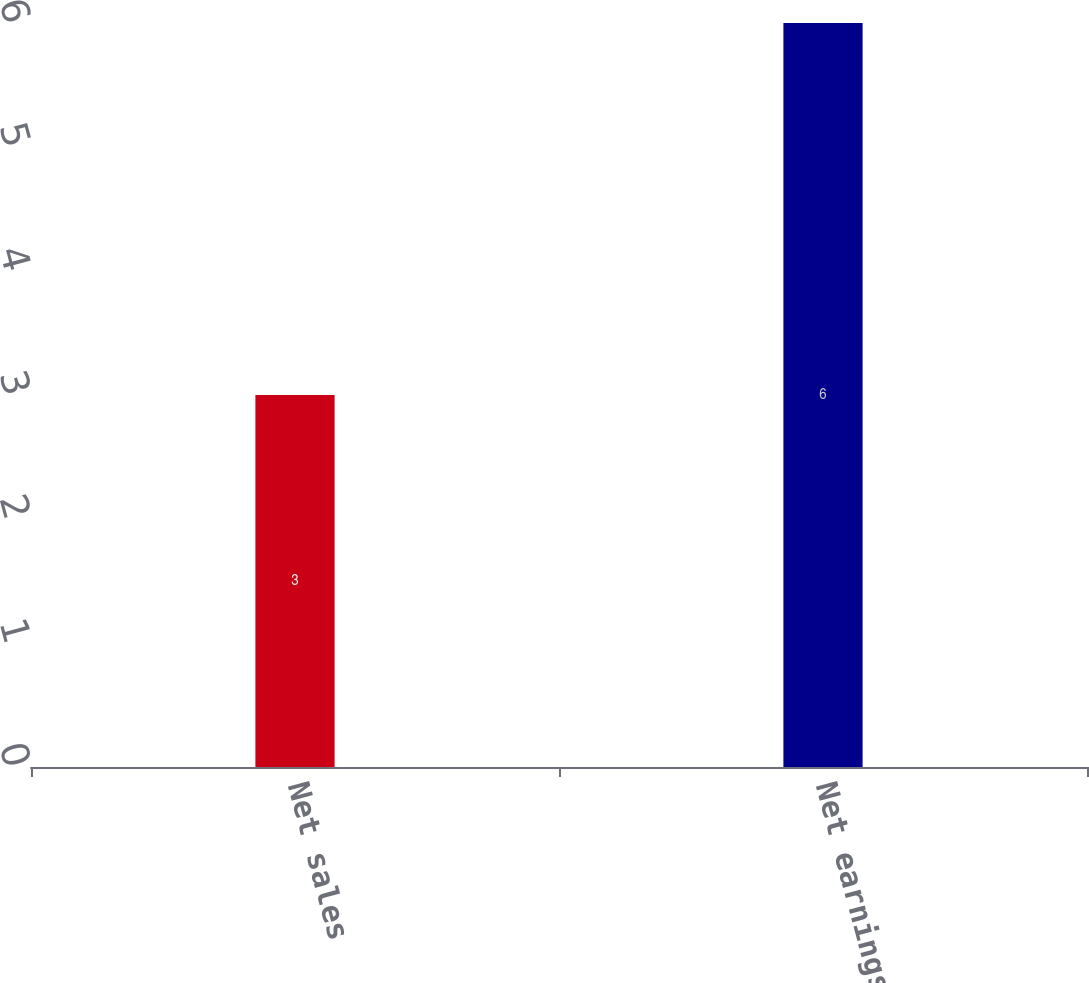<chart> <loc_0><loc_0><loc_500><loc_500><bar_chart><fcel>Net sales<fcel>Net earnings<nl><fcel>3<fcel>6<nl></chart> 